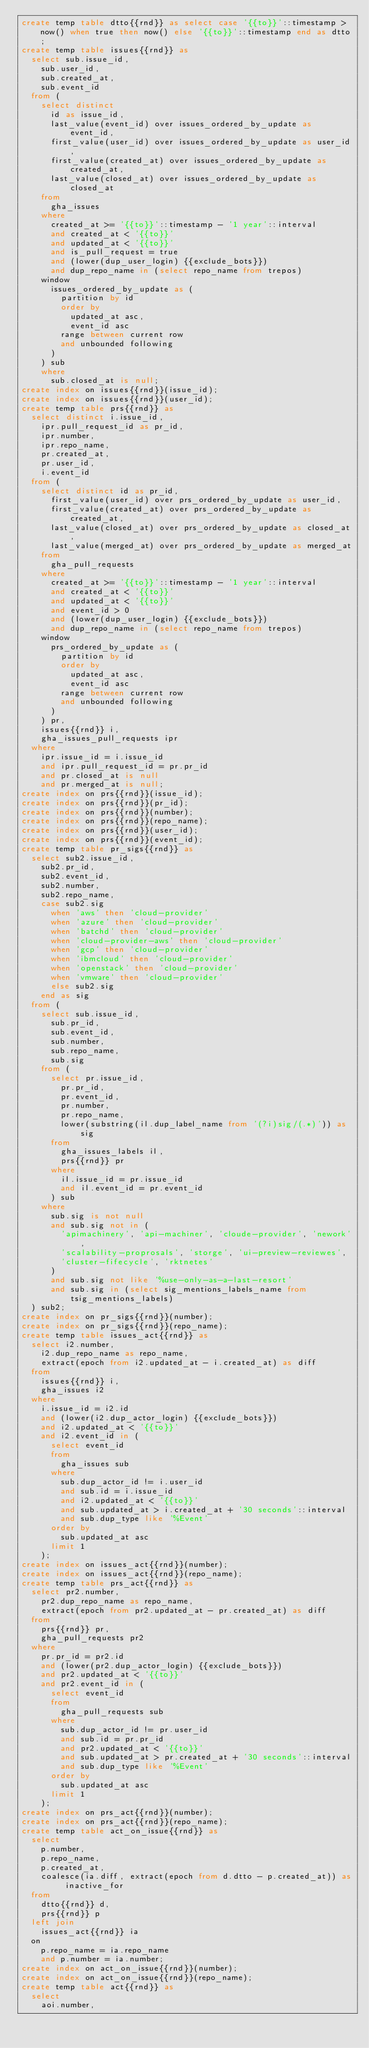Convert code to text. <code><loc_0><loc_0><loc_500><loc_500><_SQL_>create temp table dtto{{rnd}} as select case '{{to}}'::timestamp > now() when true then now() else '{{to}}'::timestamp end as dtto;
create temp table issues{{rnd}} as
  select sub.issue_id,
    sub.user_id,
    sub.created_at,
    sub.event_id
  from (
    select distinct
      id as issue_id,
      last_value(event_id) over issues_ordered_by_update as event_id,
      first_value(user_id) over issues_ordered_by_update as user_id,
      first_value(created_at) over issues_ordered_by_update as created_at,
      last_value(closed_at) over issues_ordered_by_update as closed_at
    from
      gha_issues
    where
      created_at >= '{{to}}'::timestamp - '1 year'::interval
      and created_at < '{{to}}'
      and updated_at < '{{to}}'
      and is_pull_request = true
      and (lower(dup_user_login) {{exclude_bots}})
      and dup_repo_name in (select repo_name from trepos)
    window
      issues_ordered_by_update as (
        partition by id
        order by
          updated_at asc,
          event_id asc
        range between current row
        and unbounded following
      )
    ) sub
    where
      sub.closed_at is null;
create index on issues{{rnd}}(issue_id);
create index on issues{{rnd}}(user_id);
create temp table prs{{rnd}} as
  select distinct i.issue_id,
    ipr.pull_request_id as pr_id,
    ipr.number,
    ipr.repo_name,
    pr.created_at,
    pr.user_id,
    i.event_id
  from (
    select distinct id as pr_id,
      first_value(user_id) over prs_ordered_by_update as user_id,
      first_value(created_at) over prs_ordered_by_update as created_at,
      last_value(closed_at) over prs_ordered_by_update as closed_at,
      last_value(merged_at) over prs_ordered_by_update as merged_at
    from
      gha_pull_requests
    where
      created_at >= '{{to}}'::timestamp - '1 year'::interval
      and created_at < '{{to}}'
      and updated_at < '{{to}}'
      and event_id > 0
      and (lower(dup_user_login) {{exclude_bots}})
      and dup_repo_name in (select repo_name from trepos)
    window
      prs_ordered_by_update as (
        partition by id
        order by
          updated_at asc,
          event_id asc
        range between current row
        and unbounded following
      )
    ) pr,
    issues{{rnd}} i,
    gha_issues_pull_requests ipr
  where
    ipr.issue_id = i.issue_id
    and ipr.pull_request_id = pr.pr_id
    and pr.closed_at is null
    and pr.merged_at is null;
create index on prs{{rnd}}(issue_id);
create index on prs{{rnd}}(pr_id);
create index on prs{{rnd}}(number);
create index on prs{{rnd}}(repo_name);
create index on prs{{rnd}}(user_id);
create index on prs{{rnd}}(event_id);
create temp table pr_sigs{{rnd}} as
  select sub2.issue_id,
    sub2.pr_id,
    sub2.event_id,
    sub2.number,
    sub2.repo_name,
    case sub2.sig
      when 'aws' then 'cloud-provider'
      when 'azure' then 'cloud-provider'
      when 'batchd' then 'cloud-provider'
      when 'cloud-provider-aws' then 'cloud-provider'
      when 'gcp' then 'cloud-provider'
      when 'ibmcloud' then 'cloud-provider'
      when 'openstack' then 'cloud-provider'
      when 'vmware' then 'cloud-provider'
      else sub2.sig
    end as sig
  from (
    select sub.issue_id,
      sub.pr_id,
      sub.event_id,
      sub.number,
      sub.repo_name,
      sub.sig
    from (
      select pr.issue_id,
        pr.pr_id,
        pr.event_id,
        pr.number,
        pr.repo_name,
        lower(substring(il.dup_label_name from '(?i)sig/(.*)')) as sig
      from
        gha_issues_labels il,
        prs{{rnd}} pr
      where
        il.issue_id = pr.issue_id
        and il.event_id = pr.event_id
      ) sub
    where
      sub.sig is not null
      and sub.sig not in (
        'apimachinery', 'api-machiner', 'cloude-provider', 'nework',
        'scalability-proprosals', 'storge', 'ui-preview-reviewes',
        'cluster-fifecycle', 'rktnetes'
      )
      and sub.sig not like '%use-only-as-a-last-resort'
      and sub.sig in (select sig_mentions_labels_name from tsig_mentions_labels)
  ) sub2;
create index on pr_sigs{{rnd}}(number);
create index on pr_sigs{{rnd}}(repo_name);
create temp table issues_act{{rnd}} as
  select i2.number,
    i2.dup_repo_name as repo_name,
    extract(epoch from i2.updated_at - i.created_at) as diff
  from
    issues{{rnd}} i,
    gha_issues i2
  where
    i.issue_id = i2.id
    and (lower(i2.dup_actor_login) {{exclude_bots}})
    and i2.updated_at < '{{to}}'
    and i2.event_id in (
      select event_id
      from
        gha_issues sub
      where
        sub.dup_actor_id != i.user_id
        and sub.id = i.issue_id
        and i2.updated_at < '{{to}}'
        and sub.updated_at > i.created_at + '30 seconds'::interval
        and sub.dup_type like '%Event'
      order by
        sub.updated_at asc
      limit 1
    );
create index on issues_act{{rnd}}(number);
create index on issues_act{{rnd}}(repo_name);
create temp table prs_act{{rnd}} as
  select pr2.number,
    pr2.dup_repo_name as repo_name,
    extract(epoch from pr2.updated_at - pr.created_at) as diff
  from
    prs{{rnd}} pr,
    gha_pull_requests pr2
  where
    pr.pr_id = pr2.id
    and (lower(pr2.dup_actor_login) {{exclude_bots}})
    and pr2.updated_at < '{{to}}'
    and pr2.event_id in (
      select event_id
      from
        gha_pull_requests sub
      where
        sub.dup_actor_id != pr.user_id
        and sub.id = pr.pr_id
        and pr2.updated_at < '{{to}}'
        and sub.updated_at > pr.created_at + '30 seconds'::interval
        and sub.dup_type like '%Event'
      order by
        sub.updated_at asc
      limit 1
    );
create index on prs_act{{rnd}}(number);
create index on prs_act{{rnd}}(repo_name);
create temp table act_on_issue{{rnd}} as
  select
    p.number,
    p.repo_name,
    p.created_at,
    coalesce(ia.diff, extract(epoch from d.dtto - p.created_at)) as inactive_for
  from
    dtto{{rnd}} d,
    prs{{rnd}} p
  left join
    issues_act{{rnd}} ia
  on
    p.repo_name = ia.repo_name
    and p.number = ia.number;
create index on act_on_issue{{rnd}}(number);
create index on act_on_issue{{rnd}}(repo_name);
create temp table act{{rnd}} as
  select
    aoi.number,</code> 